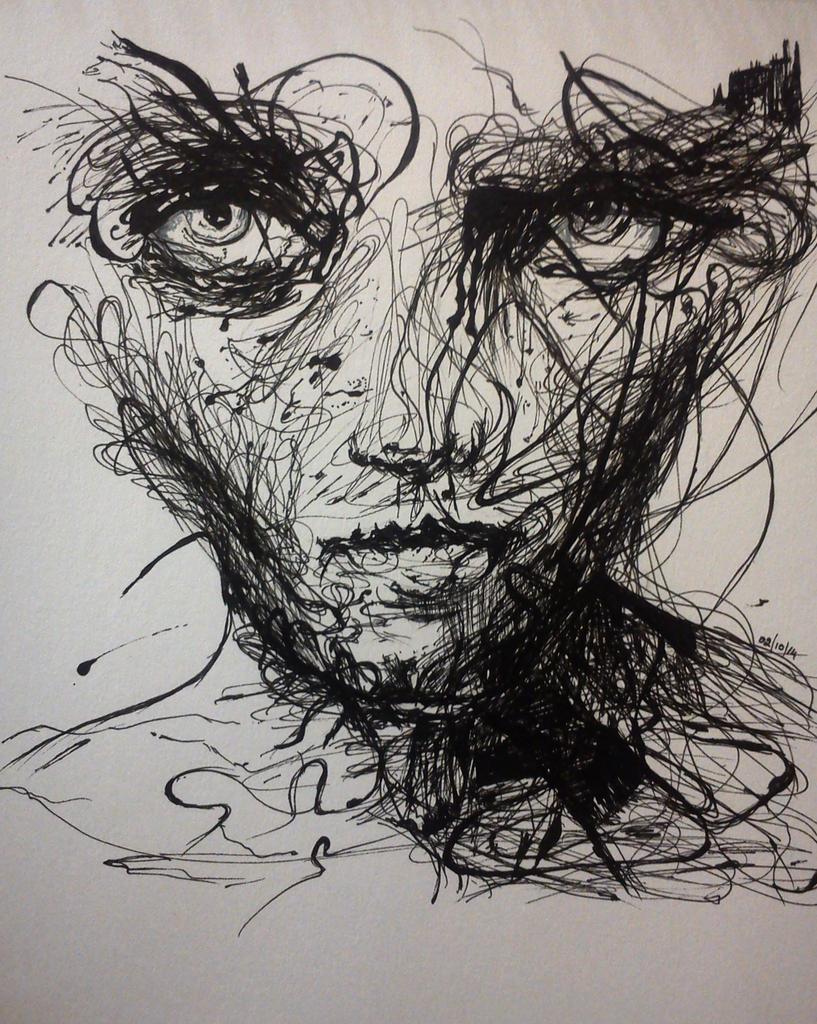In one or two sentences, can you explain what this image depicts? This is a painting and in this image, in the center there is one person. 